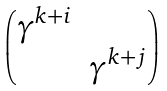<formula> <loc_0><loc_0><loc_500><loc_500>\begin{pmatrix} \gamma ^ { k + i } & \\ & \gamma ^ { k + j } \\ \end{pmatrix}</formula> 